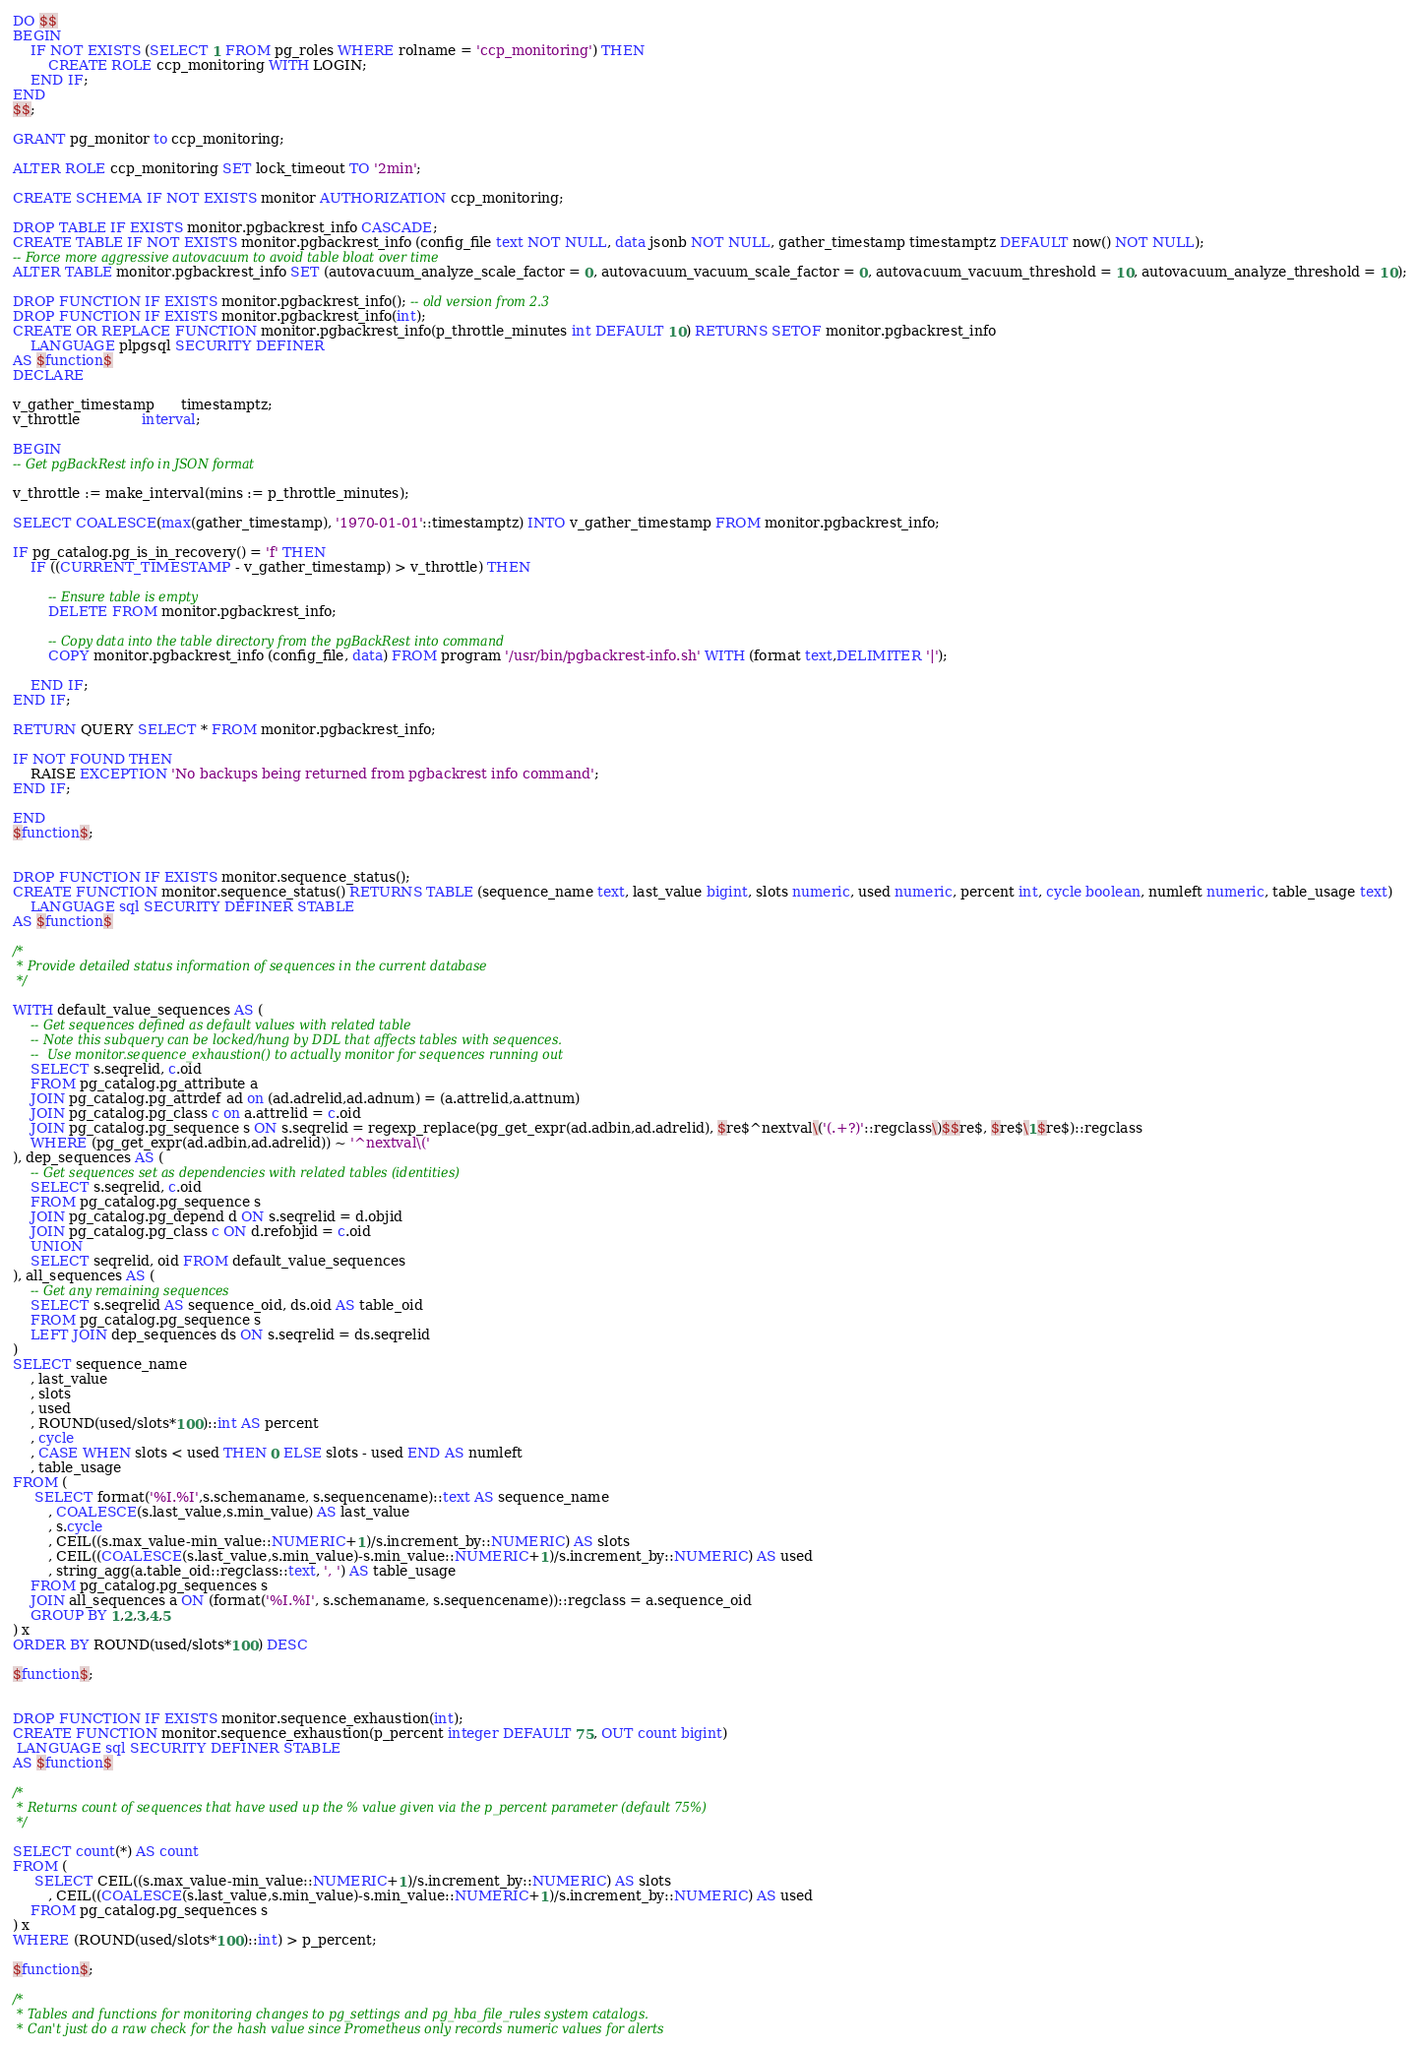Convert code to text. <code><loc_0><loc_0><loc_500><loc_500><_SQL_>DO $$
BEGIN
    IF NOT EXISTS (SELECT 1 FROM pg_roles WHERE rolname = 'ccp_monitoring') THEN
        CREATE ROLE ccp_monitoring WITH LOGIN;
    END IF;
END
$$;
 
GRANT pg_monitor to ccp_monitoring;

ALTER ROLE ccp_monitoring SET lock_timeout TO '2min';

CREATE SCHEMA IF NOT EXISTS monitor AUTHORIZATION ccp_monitoring;

DROP TABLE IF EXISTS monitor.pgbackrest_info CASCADE;
CREATE TABLE IF NOT EXISTS monitor.pgbackrest_info (config_file text NOT NULL, data jsonb NOT NULL, gather_timestamp timestamptz DEFAULT now() NOT NULL);
-- Force more aggressive autovacuum to avoid table bloat over time
ALTER TABLE monitor.pgbackrest_info SET (autovacuum_analyze_scale_factor = 0, autovacuum_vacuum_scale_factor = 0, autovacuum_vacuum_threshold = 10, autovacuum_analyze_threshold = 10);

DROP FUNCTION IF EXISTS monitor.pgbackrest_info(); -- old version from 2.3
DROP FUNCTION IF EXISTS monitor.pgbackrest_info(int);
CREATE OR REPLACE FUNCTION monitor.pgbackrest_info(p_throttle_minutes int DEFAULT 10) RETURNS SETOF monitor.pgbackrest_info
    LANGUAGE plpgsql SECURITY DEFINER
AS $function$
DECLARE

v_gather_timestamp      timestamptz;
v_throttle              interval;
 
BEGIN
-- Get pgBackRest info in JSON format

v_throttle := make_interval(mins := p_throttle_minutes);

SELECT COALESCE(max(gather_timestamp), '1970-01-01'::timestamptz) INTO v_gather_timestamp FROM monitor.pgbackrest_info;

IF pg_catalog.pg_is_in_recovery() = 'f' THEN
    IF ((CURRENT_TIMESTAMP - v_gather_timestamp) > v_throttle) THEN

        -- Ensure table is empty 
        DELETE FROM monitor.pgbackrest_info;

        -- Copy data into the table directory from the pgBackRest into command
        COPY monitor.pgbackrest_info (config_file, data) FROM program '/usr/bin/pgbackrest-info.sh' WITH (format text,DELIMITER '|');

    END IF;
END IF;

RETURN QUERY SELECT * FROM monitor.pgbackrest_info;

IF NOT FOUND THEN
    RAISE EXCEPTION 'No backups being returned from pgbackrest info command';
END IF;

END 
$function$;


DROP FUNCTION IF EXISTS monitor.sequence_status();
CREATE FUNCTION monitor.sequence_status() RETURNS TABLE (sequence_name text, last_value bigint, slots numeric, used numeric, percent int, cycle boolean, numleft numeric, table_usage text)  
    LANGUAGE sql SECURITY DEFINER STABLE
AS $function$

/* 
 * Provide detailed status information of sequences in the current database
 */

WITH default_value_sequences AS (
    -- Get sequences defined as default values with related table
    -- Note this subquery can be locked/hung by DDL that affects tables with sequences. 
    --  Use monitor.sequence_exhaustion() to actually monitor for sequences running out
    SELECT s.seqrelid, c.oid 
    FROM pg_catalog.pg_attribute a
    JOIN pg_catalog.pg_attrdef ad on (ad.adrelid,ad.adnum) = (a.attrelid,a.attnum)
    JOIN pg_catalog.pg_class c on a.attrelid = c.oid
    JOIN pg_catalog.pg_sequence s ON s.seqrelid = regexp_replace(pg_get_expr(ad.adbin,ad.adrelid), $re$^nextval\('(.+?)'::regclass\)$$re$, $re$\1$re$)::regclass
    WHERE (pg_get_expr(ad.adbin,ad.adrelid)) ~ '^nextval\('
), dep_sequences AS (
    -- Get sequences set as dependencies with related tables (identities)    
    SELECT s.seqrelid, c.oid
    FROM pg_catalog.pg_sequence s 
    JOIN pg_catalog.pg_depend d ON s.seqrelid = d.objid
    JOIN pg_catalog.pg_class c ON d.refobjid = c.oid
    UNION
    SELECT seqrelid, oid FROM default_value_sequences
), all_sequences AS (
    -- Get any remaining sequences
    SELECT s.seqrelid AS sequence_oid, ds.oid AS table_oid
    FROM pg_catalog.pg_sequence s
    LEFT JOIN dep_sequences ds ON s.seqrelid = ds.seqrelid
)
SELECT sequence_name
    , last_value
    , slots
    , used
    , ROUND(used/slots*100)::int AS percent
    , cycle
    , CASE WHEN slots < used THEN 0 ELSE slots - used END AS numleft
    , table_usage
FROM (
     SELECT format('%I.%I',s.schemaname, s.sequencename)::text AS sequence_name
        , COALESCE(s.last_value,s.min_value) AS last_value
        , s.cycle
        , CEIL((s.max_value-min_value::NUMERIC+1)/s.increment_by::NUMERIC) AS slots
        , CEIL((COALESCE(s.last_value,s.min_value)-s.min_value::NUMERIC+1)/s.increment_by::NUMERIC) AS used
        , string_agg(a.table_oid::regclass::text, ', ') AS table_usage
    FROM pg_catalog.pg_sequences s
    JOIN all_sequences a ON (format('%I.%I', s.schemaname, s.sequencename))::regclass = a.sequence_oid
    GROUP BY 1,2,3,4,5
) x 
ORDER BY ROUND(used/slots*100) DESC

$function$;


DROP FUNCTION IF EXISTS monitor.sequence_exhaustion(int);
CREATE FUNCTION monitor.sequence_exhaustion(p_percent integer DEFAULT 75, OUT count bigint)
 LANGUAGE sql SECURITY DEFINER STABLE
AS $function$

/* 
 * Returns count of sequences that have used up the % value given via the p_percent parameter (default 75%)
 */

SELECT count(*) AS count
FROM (
     SELECT CEIL((s.max_value-min_value::NUMERIC+1)/s.increment_by::NUMERIC) AS slots
        , CEIL((COALESCE(s.last_value,s.min_value)-s.min_value::NUMERIC+1)/s.increment_by::NUMERIC) AS used
    FROM pg_catalog.pg_sequences s
) x 
WHERE (ROUND(used/slots*100)::int) > p_percent;

$function$;

/*
 * Tables and functions for monitoring changes to pg_settings and pg_hba_file_rules system catalogs.
 * Can't just do a raw check for the hash value since Prometheus only records numeric values for alerts</code> 